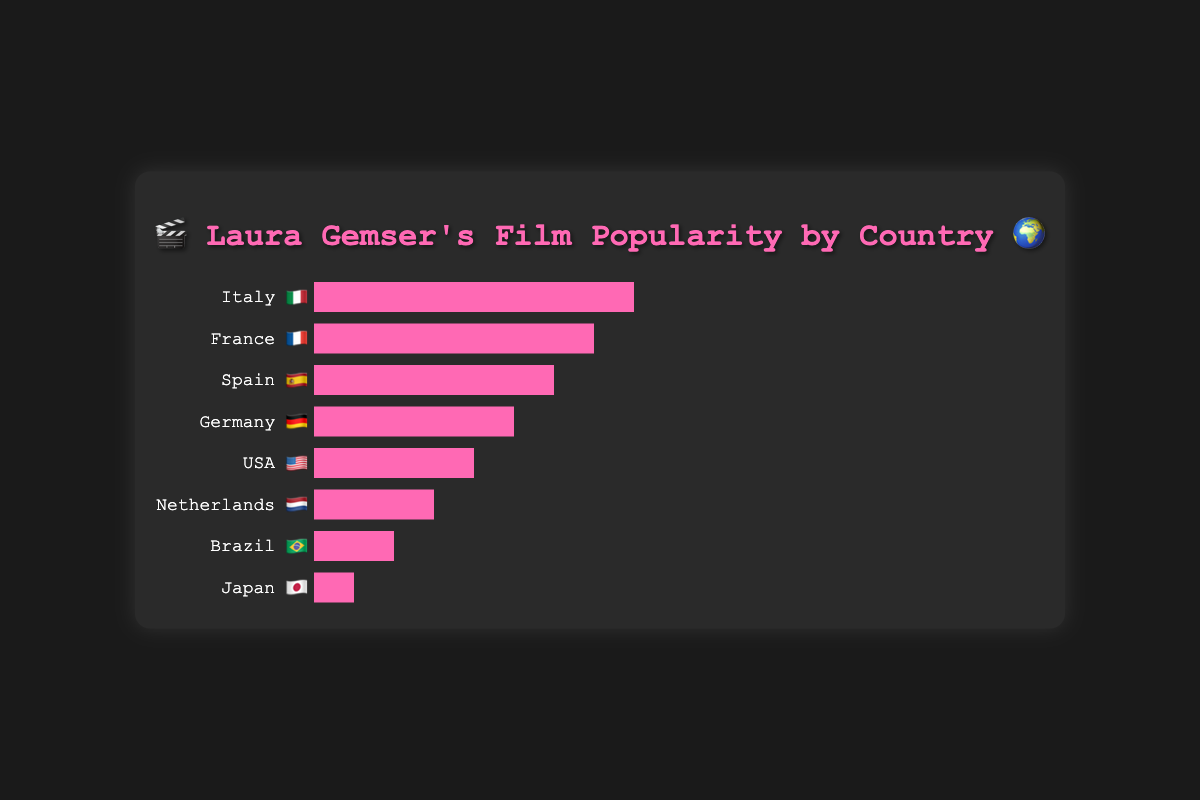What is the most popular country for Laura Gemser's films? To find the most popular country, we look for the country with the longest bar in the chart. Italy has the longest bar with a width representing a popularity score of 8.
Answer: Italy 🇮🇹 Which country has a popularity score of 4 for Laura Gemser's films? We identify the country with a bar that corresponds to a width indicating a popularity score of 4. The USA has the bar of appropriate length for a score of 4.
Answer: USA 🇺🇸 By how much does the popularity of Laura Gemser's films in France exceed that in Spain? France has a popularity score of 7 while Spain has a score of 6. The difference between these two scores is 7 - 6.
Answer: 1 What is the total popularity score when combining Brazil and Japan? Brazil has a popularity score of 2 and Japan has a score of 1. Summing these two values gives us 2 + 1.
Answer: 3 Which country has a smaller popularity score than the Netherlands but higher than Japan? To find this, look for a country with a score between 3 (Netherlands) and 1 (Japan). Brazil fits this description with a popularity score of 2.
Answer: Brazil 🇧🇷 Which countries have a score higher than 5? The countries that have bars longer than the one representing a score of 5 are Italy (8), France (7), and Spain (6).
Answer: Italy 🇮🇹, France 🇫🇷, Spain 🇪🇸 What is the combined difference in popularity scores between the top 3 and bottom 3 countries? The top 3 countries have scores of Italy (8), France (7), and Spain (6). The bottom 3 countries are Netherlands (3), Brazil (2), and Japan (1). The combined difference is (8 + 7 + 6) - (3 + 2 + 1).
Answer: 15 